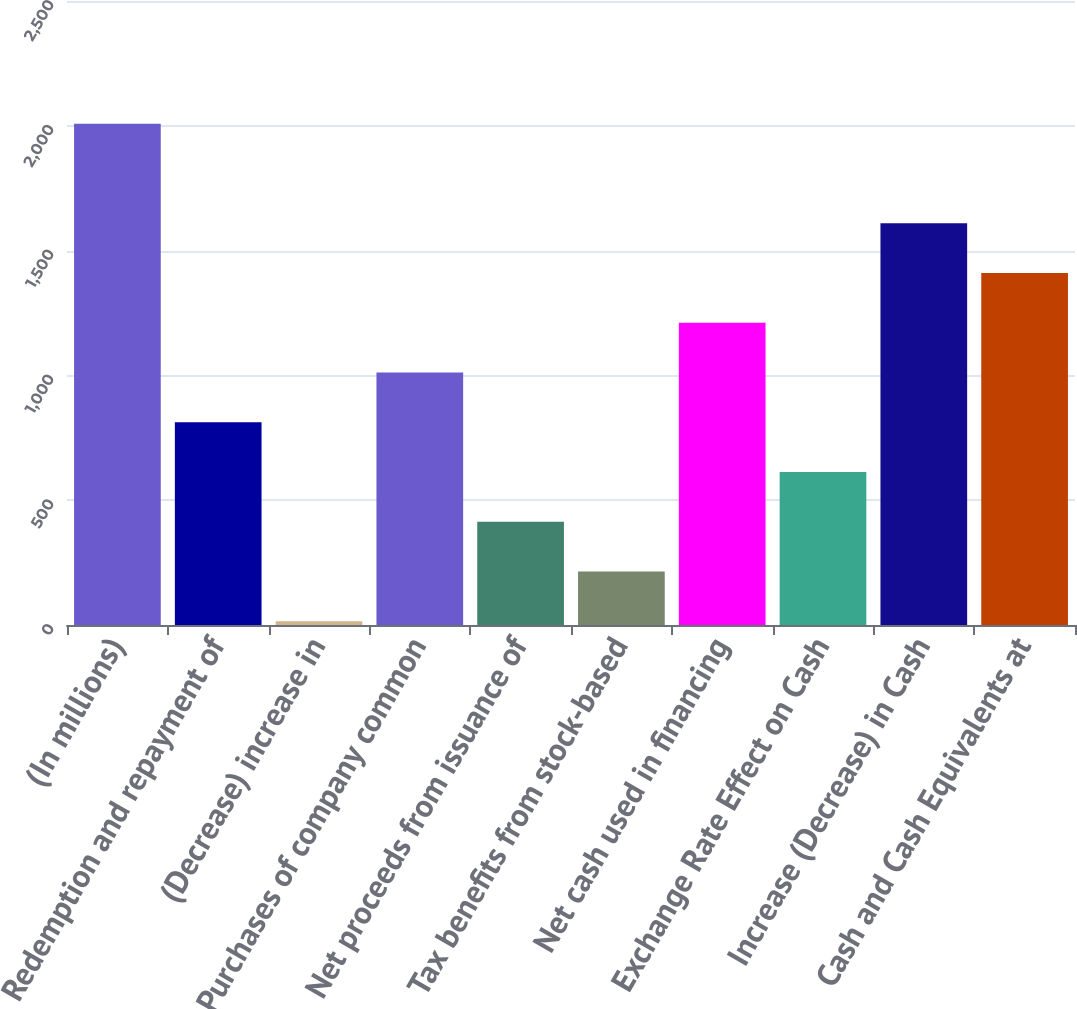Convert chart to OTSL. <chart><loc_0><loc_0><loc_500><loc_500><bar_chart><fcel>(In millions)<fcel>Redemption and repayment of<fcel>(Decrease) increase in<fcel>Purchases of company common<fcel>Net proceeds from issuance of<fcel>Tax benefits from stock-based<fcel>Net cash used in financing<fcel>Exchange Rate Effect on Cash<fcel>Increase (Decrease) in Cash<fcel>Cash and Cash Equivalents at<nl><fcel>2008<fcel>812.44<fcel>15.4<fcel>1011.7<fcel>413.92<fcel>214.66<fcel>1210.96<fcel>613.18<fcel>1609.48<fcel>1410.22<nl></chart> 